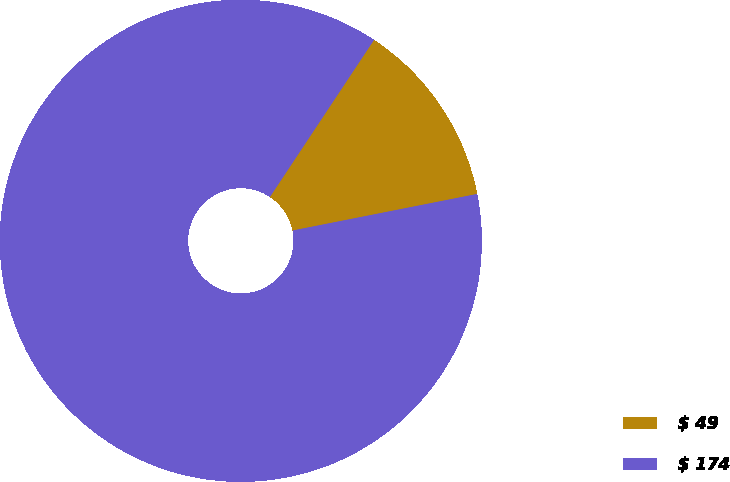<chart> <loc_0><loc_0><loc_500><loc_500><pie_chart><fcel>$ 49<fcel>$ 174<nl><fcel>12.57%<fcel>87.43%<nl></chart> 